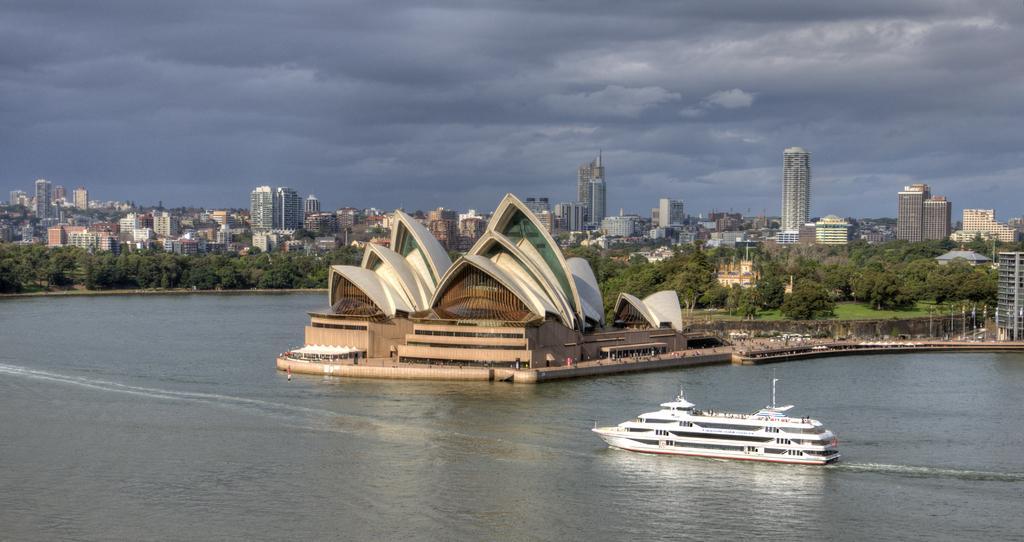Describe this image in one or two sentences. In the image I can see a ocean in which there is a boat and I can see a path on which there is a building and also I can see some buildings, trees and some trees and plants. 